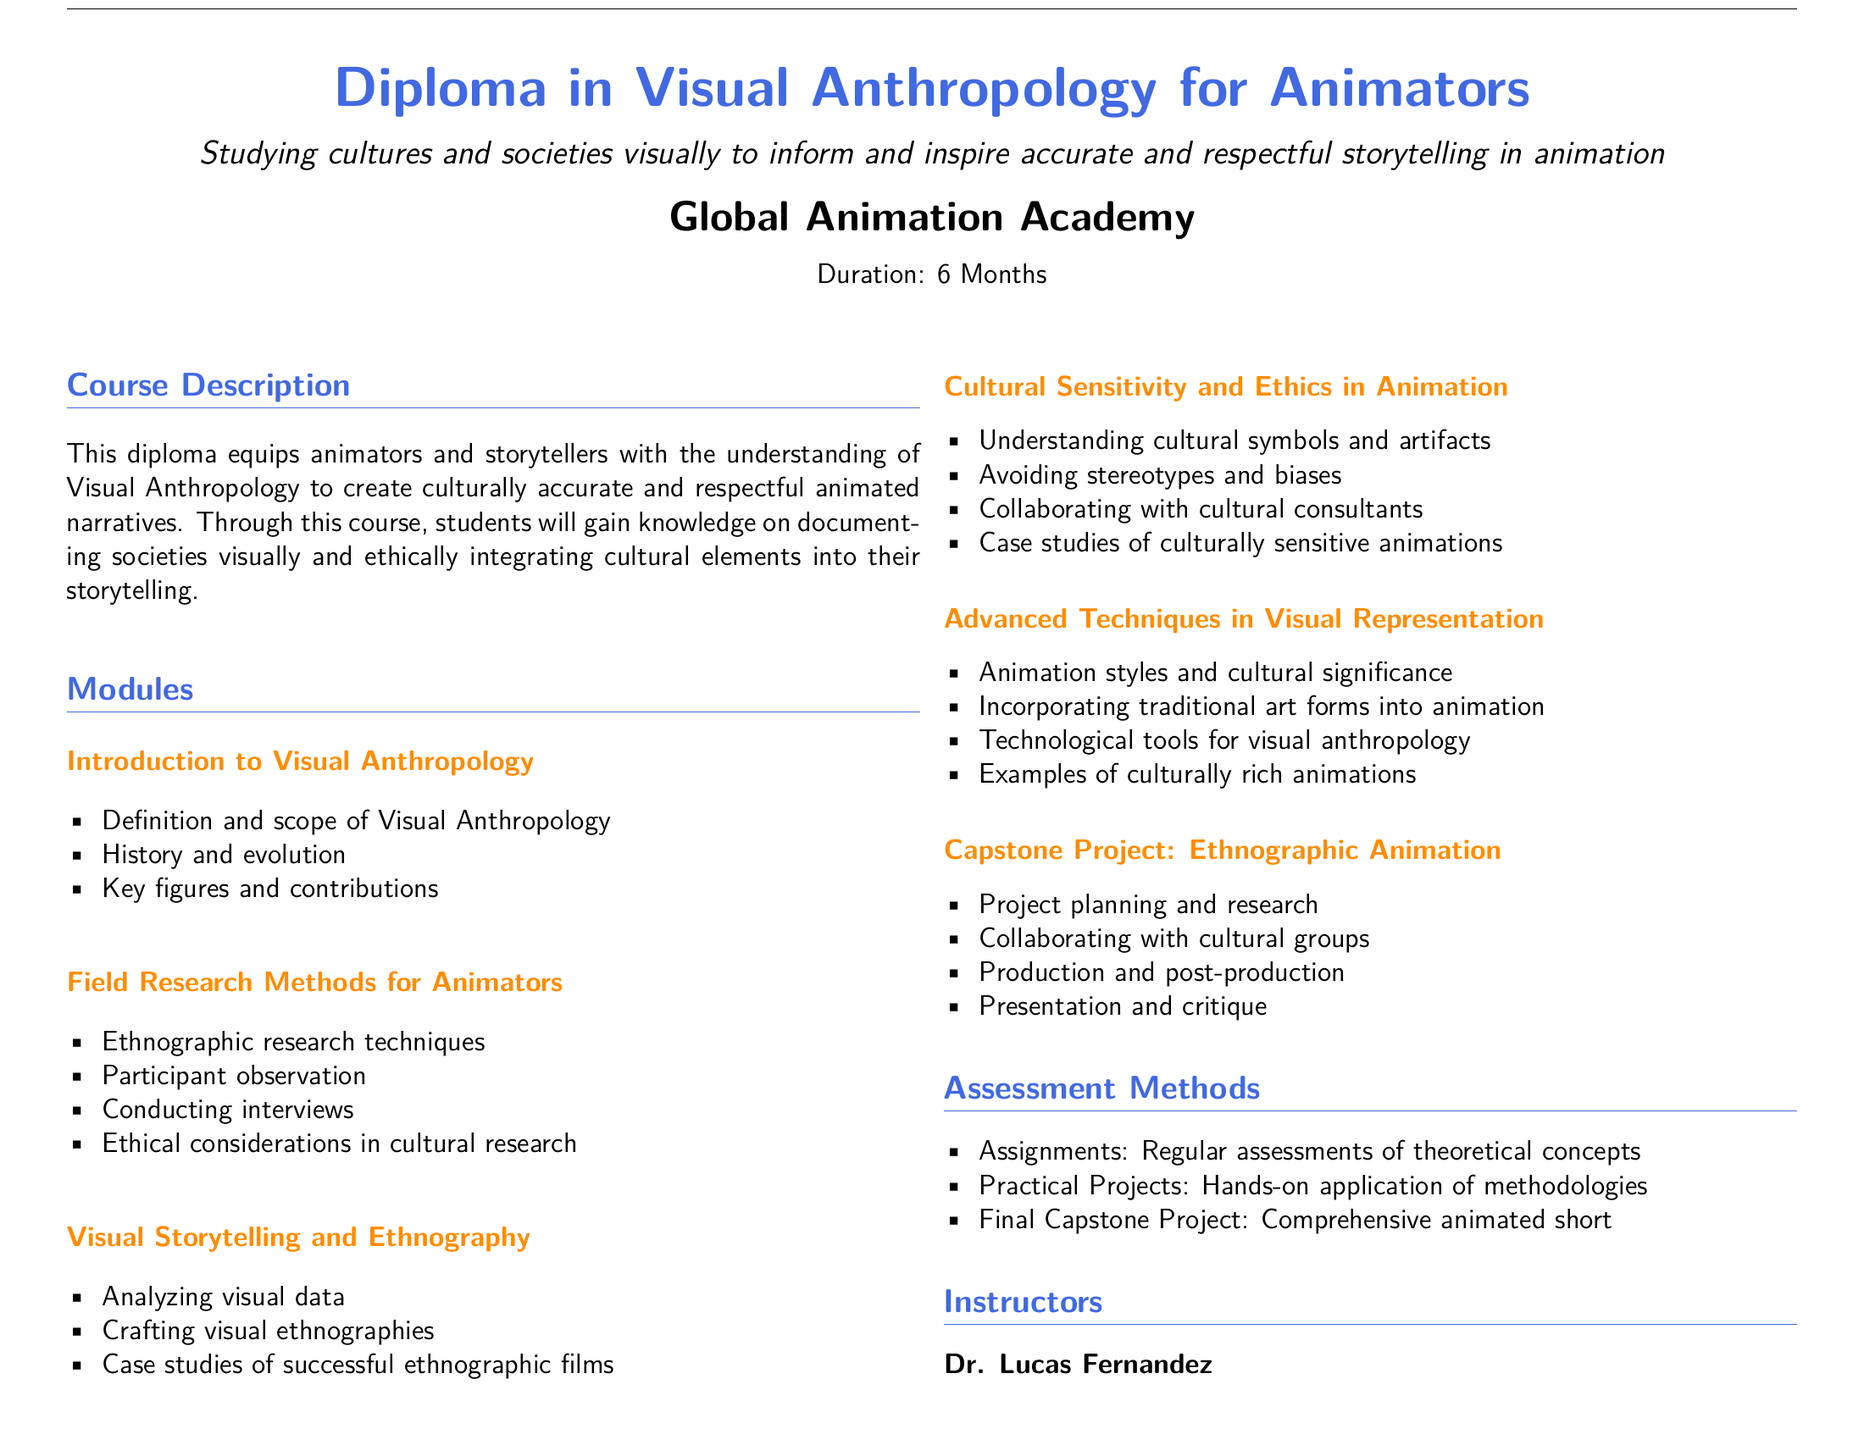What is the duration of the course? The duration of the course is explicitly stated in the document under Course Description.
Answer: 6 Months Who is the instructor with a PhD in Visual Anthropology? The document provides the names and qualifications of the instructors.
Answer: Dr. Lucas Fernandez What is the focus of the Capstone Project? This is detailed in the Capstone Project section, specifying what students will work on.
Answer: Ethnographic Animation Name one module that addresses ethical considerations. The document lists modules, including one dedicated to ethics.
Answer: Cultural Sensitivity and Ethics in Animation How many modules are there in total? The document outlines the modules listed and provides a total count.
Answer: Six Which technique is emphasized for field research? The document lists specific methods in the Field Research Methods for Animators section.
Answer: Ethnographic research techniques What is the assessment method that involves practical application? This is listed under Assessment Methods, which describes the types of assessments students will undertake.
Answer: Practical Projects Who has experience in cultural animation? The document describes the experience of the instructors, focusing on their backgrounds.
Answer: Prof. Amanda Lee 